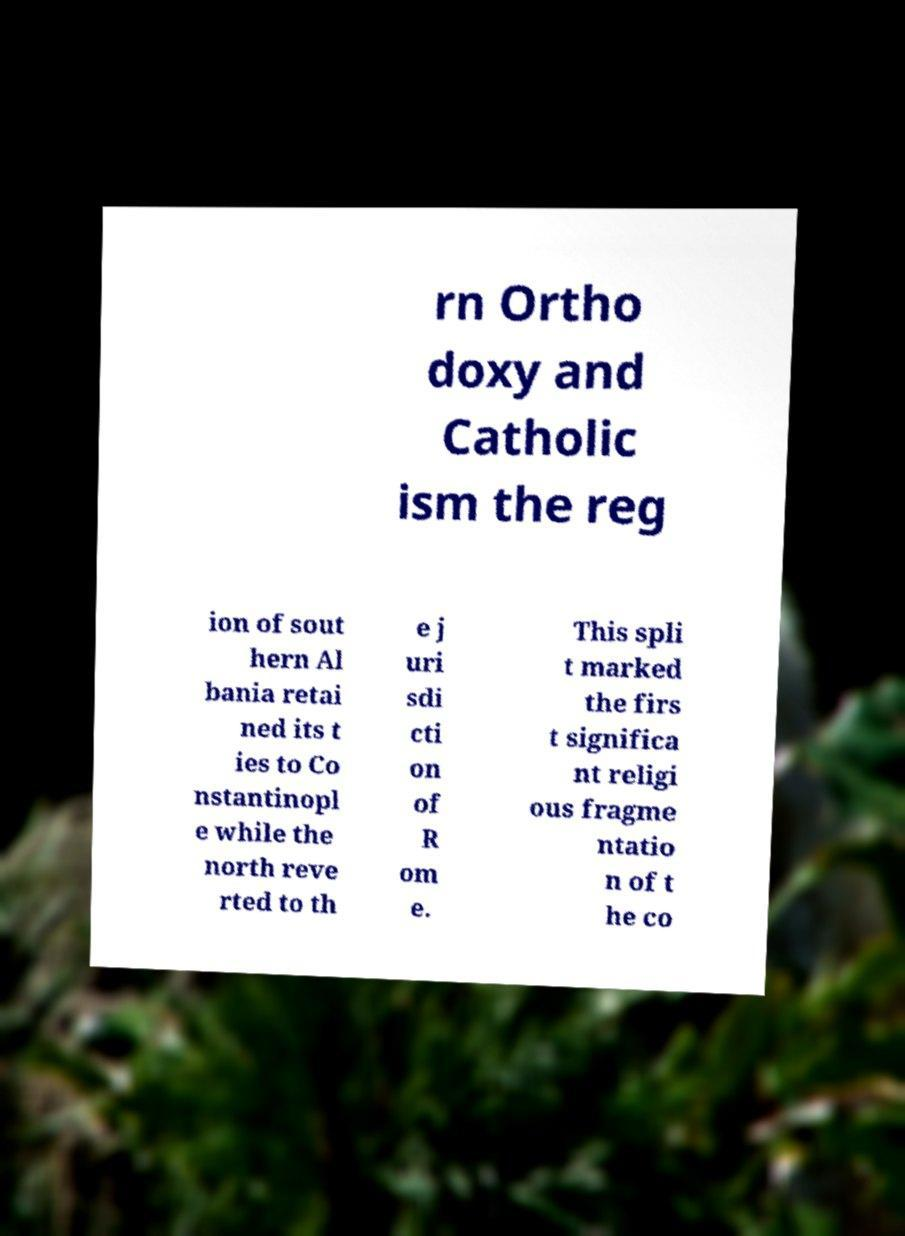There's text embedded in this image that I need extracted. Can you transcribe it verbatim? rn Ortho doxy and Catholic ism the reg ion of sout hern Al bania retai ned its t ies to Co nstantinopl e while the north reve rted to th e j uri sdi cti on of R om e. This spli t marked the firs t significa nt religi ous fragme ntatio n of t he co 